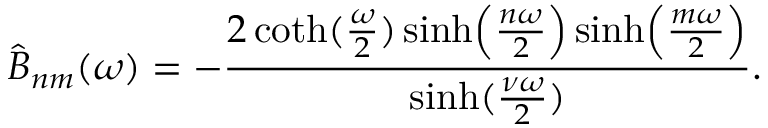Convert formula to latex. <formula><loc_0><loc_0><loc_500><loc_500>\hat { B } _ { n m } ( \omega ) = - { \frac { 2 \coth ( { \frac { \omega } { 2 } } ) \sinh \left ( { \frac { n \omega } { 2 } } \right ) \sinh \left ( { \frac { m \omega } { 2 } } \right ) } { \sinh ( { \frac { \nu \omega } { 2 } } ) } } .</formula> 